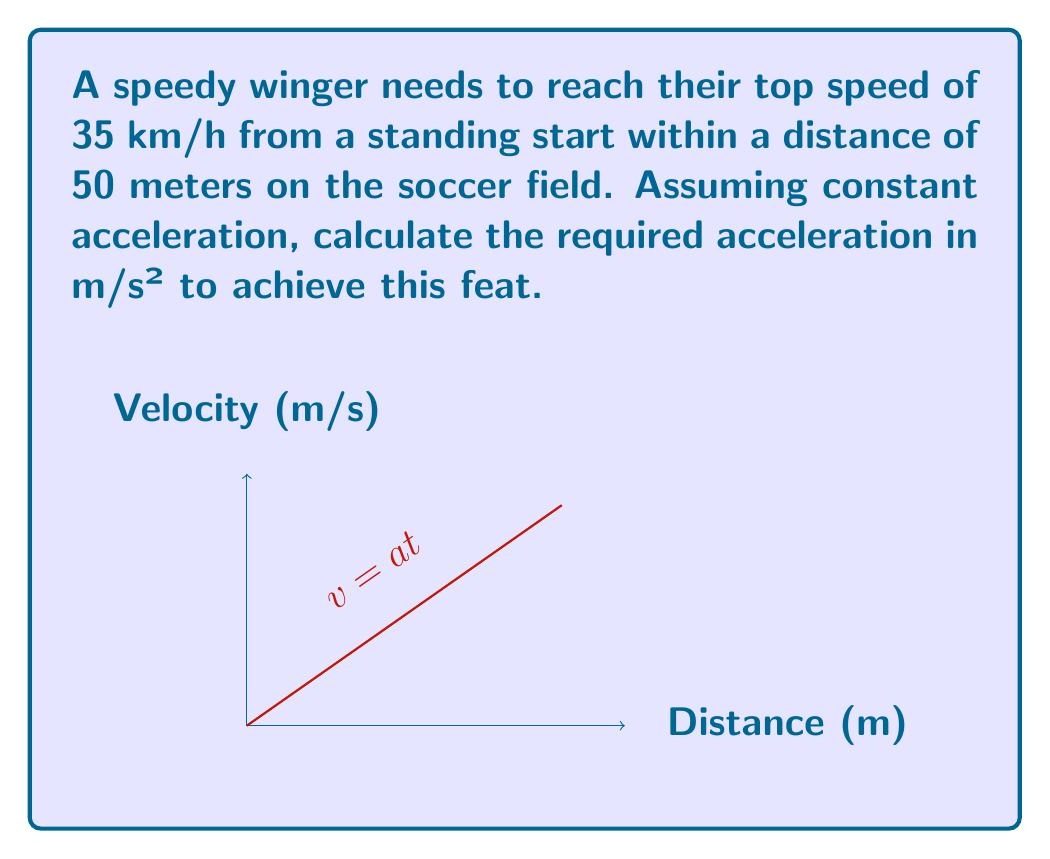Help me with this question. To solve this problem, we'll use the equations of motion for constant acceleration. Let's break it down step-by-step:

1) First, let's convert the top speed from km/h to m/s:
   $$ v = 35 \text{ km/h} = 35 \cdot \frac{1000 \text{ m}}{3600 \text{ s}} \approx 9.72 \text{ m/s} $$

2) We'll use the equation that relates displacement (s), initial velocity (u), final velocity (v), and acceleration (a):
   $$ s = ut + \frac{1}{2}at^2 $$
   
   Where t is the time taken to reach the final velocity.

3) Since the winger starts from rest, initial velocity u = 0. We can simplify the equation to:
   $$ s = \frac{1}{2}at^2 $$

4) We also know that for constant acceleration:
   $$ v = at $$

5) Solving this for t:
   $$ t = \frac{v}{a} $$

6) Substituting this into our displacement equation:
   $$ s = \frac{1}{2}a(\frac{v}{a})^2 = \frac{v^2}{2a} $$

7) Now we can solve for a:
   $$ a = \frac{v^2}{2s} $$

8) Plugging in our values (v = 9.72 m/s, s = 50 m):
   $$ a = \frac{(9.72 \text{ m/s})^2}{2(50 \text{ m})} \approx 0.945 \text{ m/s}^2 $$

Therefore, the required acceleration is approximately 0.945 m/s².
Answer: $0.945 \text{ m/s}^2$ 